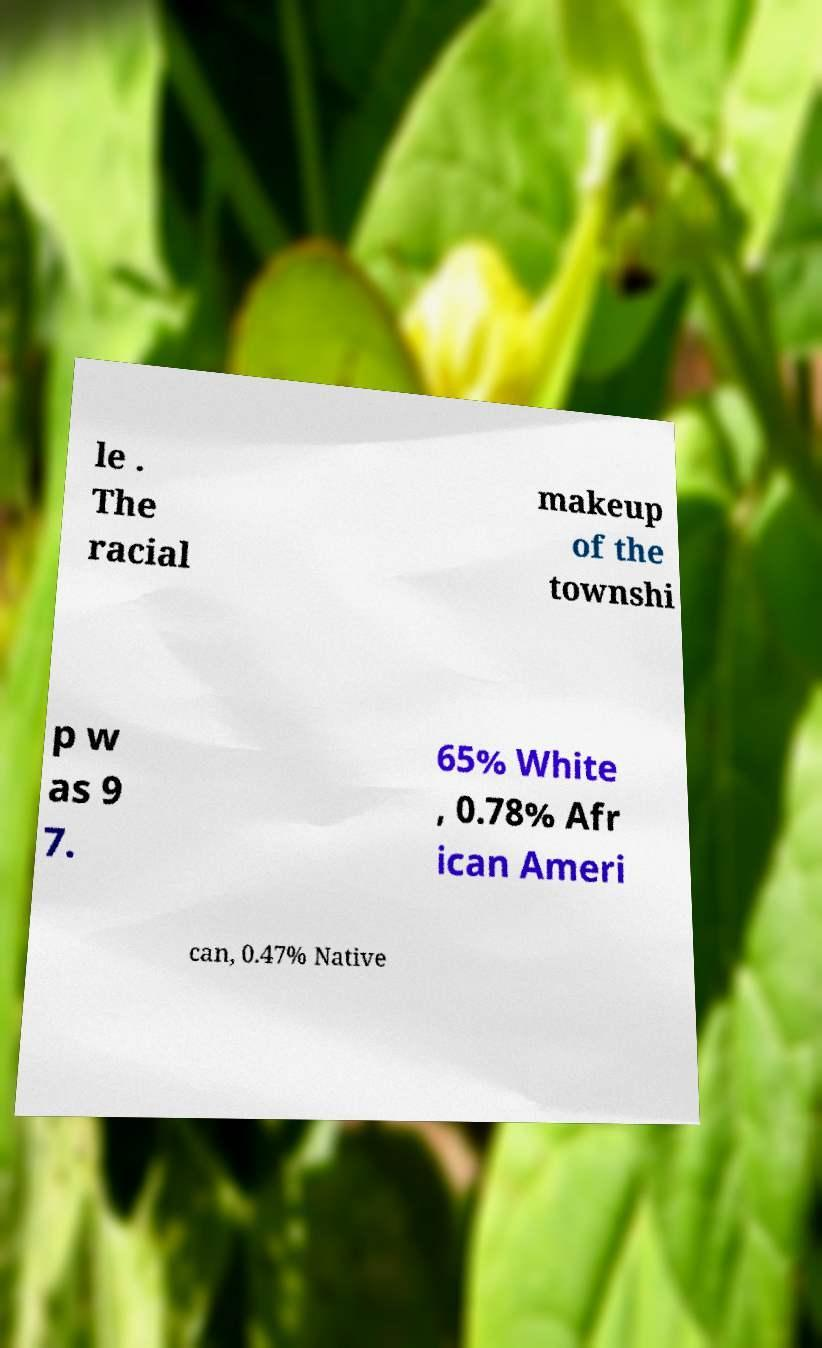Please identify and transcribe the text found in this image. le . The racial makeup of the townshi p w as 9 7. 65% White , 0.78% Afr ican Ameri can, 0.47% Native 